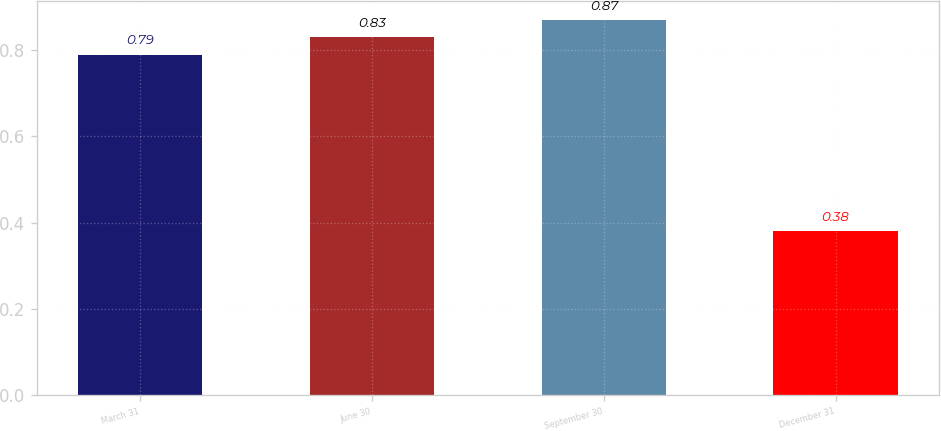<chart> <loc_0><loc_0><loc_500><loc_500><bar_chart><fcel>March 31<fcel>June 30<fcel>September 30<fcel>December 31<nl><fcel>0.79<fcel>0.83<fcel>0.87<fcel>0.38<nl></chart> 